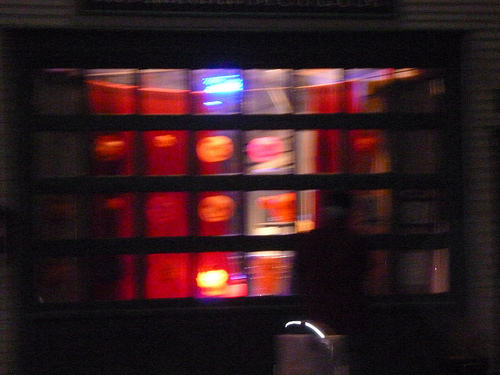<image>
Is the light in the window? No. The light is not contained within the window. These objects have a different spatial relationship. 